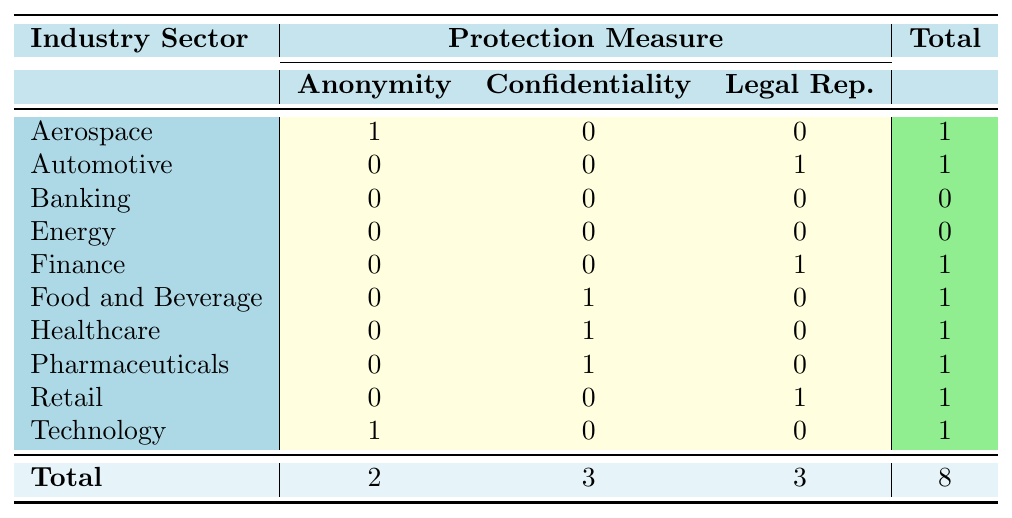What is the total number of whistleblower cases listed in the table? The table shows a total of 8 whistleblower cases, as indicated in the last row under the ‘Total’ column.
Answer: 8 How many whistleblower cases in the Technology sector involved anonymity as a protection measure? There is 1 case in the Technology sector listed under the Anonymity protection measure, shown in the corresponding cell of the table.
Answer: 1 Did any case in the Energy sector result in conviction? No, there are 0 cases resulting in conviction as indicated by the zero in the Banking and Energy sectors.
Answer: No What is the total number of whistleblower cases that involved confidentiality agreements? We can see from the table that there are 3 cases involving confidentiality agreements listed under the corresponding column.
Answer: 3 Which industry sector has the highest number of whistleblower cases? Each industry sector has at most 1 case listed, so none of them has more than 1. Hence they all tie in the number of cases.
Answer: None How many cases in the Finance and Automotive sectors were adjudicated? In finance, there is 1 case classified as a conviction, and in automotive, there is 1 case which was dismissed. Adding both gives us 1 + 1 = 2 cases that were adjudicated.
Answer: 2 What is the total number of whistleblower cases that came to a settlement outcome? The Healthcare sector has 1, the Energy sector has 1, Pharmaceuticals have 1, and Retail has 1, which sums to 4 settlement outcomes in total as indicated in the 'outcome' column.
Answer: 4 Is there any sector that has exclusively used anonymity as a protection measure? Yes, the Technology sector exclusively used anonymity, as seen in the table, while no others have exclusively used this measure.
Answer: Yes 